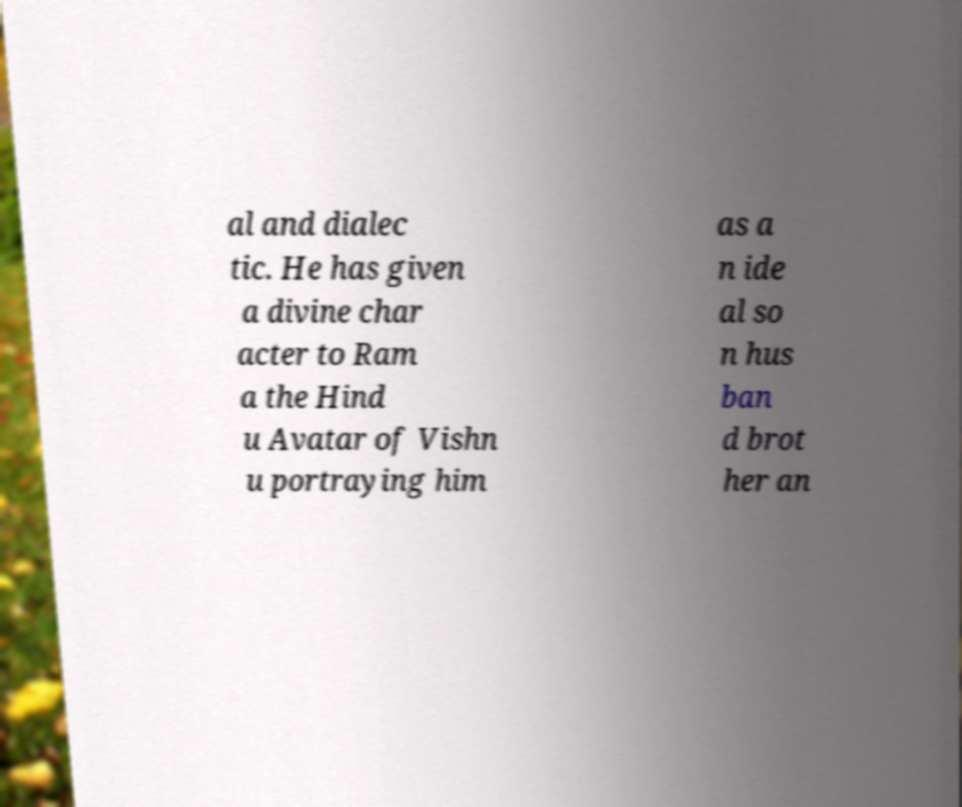For documentation purposes, I need the text within this image transcribed. Could you provide that? al and dialec tic. He has given a divine char acter to Ram a the Hind u Avatar of Vishn u portraying him as a n ide al so n hus ban d brot her an 